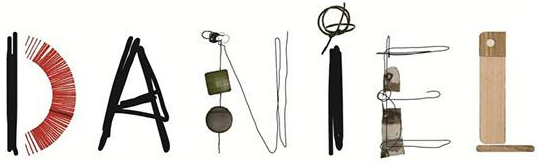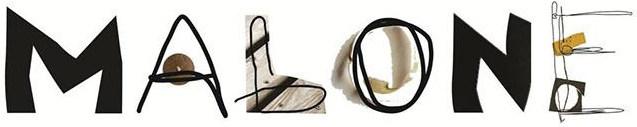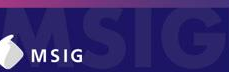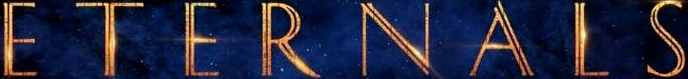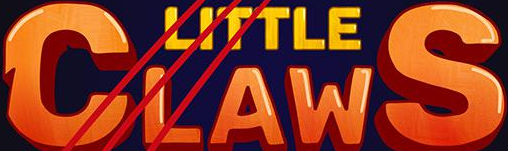Transcribe the words shown in these images in order, separated by a semicolon. DANiEL; MALONE; MSIG; ETERNALS; CLAWS 